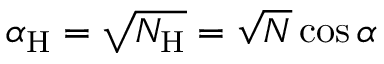Convert formula to latex. <formula><loc_0><loc_0><loc_500><loc_500>\alpha _ { H } = \sqrt { N _ { H } } = \sqrt { N } \cos \alpha</formula> 